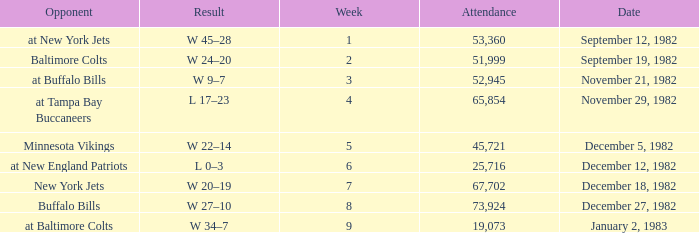What is the result of the game with an attendance greater than 67,702? W 27–10. 